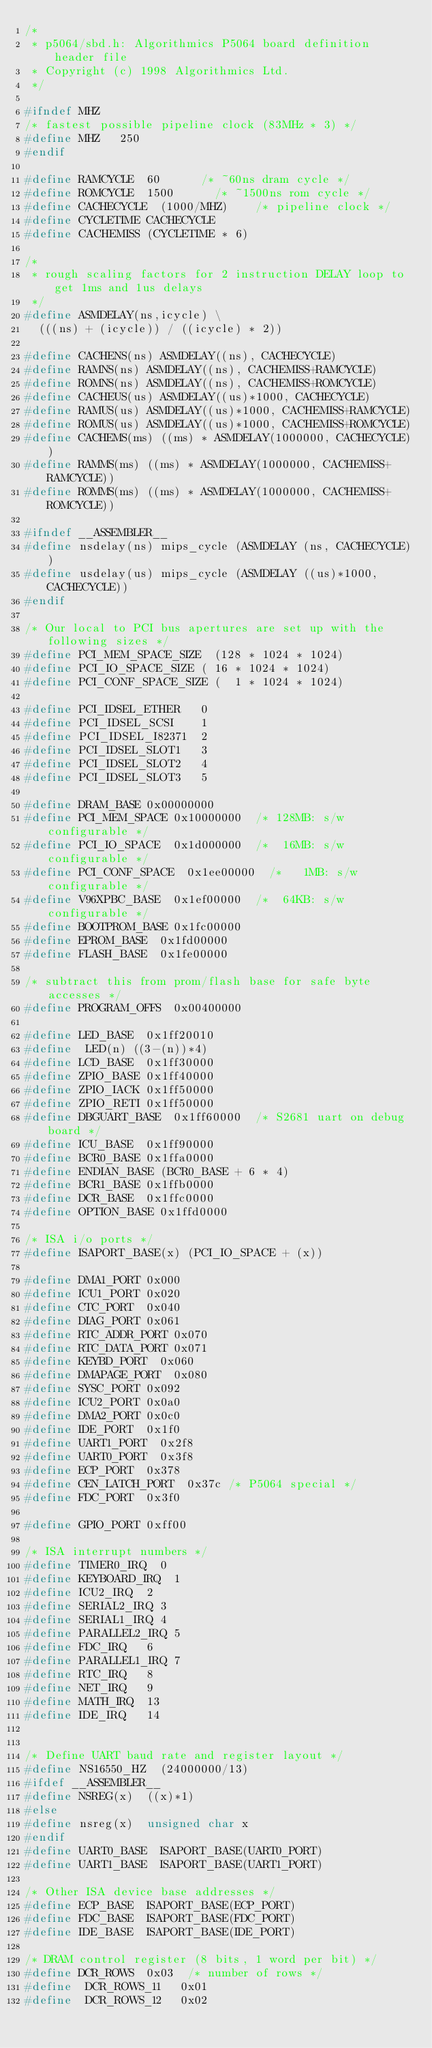<code> <loc_0><loc_0><loc_500><loc_500><_C_>/* 
 * p5064/sbd.h: Algorithmics P5064 board definition header file
 * Copyright (c) 1998 Algorithmics Ltd.
 */

#ifndef MHZ
/* fastest possible pipeline clock (83MHz * 3) */
#define MHZ		250
#endif

#define RAMCYCLE	60			/* ~60ns dram cycle */
#define ROMCYCLE	1500			/* ~1500ns rom cycle */
#define CACHECYCLE	(1000/MHZ) 		/* pipeline clock */
#define CYCLETIME	CACHECYCLE
#define CACHEMISS	(CYCLETIME * 6)

/*
 * rough scaling factors for 2 instruction DELAY loop to get 1ms and 1us delays
 */
#define ASMDELAY(ns,icycle)	\
	(((ns) + (icycle)) / ((icycle) * 2))

#define CACHENS(ns)	ASMDELAY((ns), CACHECYCLE)
#define RAMNS(ns)	ASMDELAY((ns), CACHEMISS+RAMCYCLE)
#define ROMNS(ns)	ASMDELAY((ns), CACHEMISS+ROMCYCLE)
#define CACHEUS(us)	ASMDELAY((us)*1000, CACHECYCLE)
#define RAMUS(us)	ASMDELAY((us)*1000, CACHEMISS+RAMCYCLE)
#define ROMUS(us)	ASMDELAY((us)*1000, CACHEMISS+ROMCYCLE)
#define CACHEMS(ms)	((ms) * ASMDELAY(1000000, CACHECYCLE))
#define RAMMS(ms)	((ms) * ASMDELAY(1000000, CACHEMISS+RAMCYCLE))
#define ROMMS(ms)	((ms) * ASMDELAY(1000000, CACHEMISS+ROMCYCLE))

#ifndef __ASSEMBLER__
#define nsdelay(ns)	mips_cycle (ASMDELAY (ns, CACHECYCLE))
#define usdelay(us)	mips_cycle (ASMDELAY ((us)*1000, CACHECYCLE))
#endif

/* Our local to PCI bus apertures are set up with the following sizes */
#define PCI_MEM_SPACE_SIZE	(128 * 1024 * 1024)
#define PCI_IO_SPACE_SIZE	( 16 * 1024 * 1024)
#define PCI_CONF_SPACE_SIZE	(  1 * 1024 * 1024)

#define PCI_IDSEL_ETHER		0
#define PCI_IDSEL_SCSI		1
#define PCI_IDSEL_I82371	2
#define PCI_IDSEL_SLOT1		3
#define PCI_IDSEL_SLOT2		4
#define PCI_IDSEL_SLOT3		5

#define DRAM_BASE	0x00000000
#define PCI_MEM_SPACE	0x10000000	/* 128MB: s/w configurable */
#define PCI_IO_SPACE	0x1d000000	/*  16MB: s/w configurable */
#define PCI_CONF_SPACE	0x1ee00000	/*   1MB: s/w configurable */
#define V96XPBC_BASE	0x1ef00000	/*  64KB: s/w configurable */
#define BOOTPROM_BASE	0x1fc00000
#define EPROM_BASE	0x1fd00000
#define FLASH_BASE	0x1fe00000

/* subtract this from prom/flash base for safe byte accesses */
#define PROGRAM_OFFS	0x00400000

#define LED_BASE	0x1ff20010
#define  LED(n)	((3-(n))*4)
#define LCD_BASE	0x1ff30000
#define ZPIO_BASE	0x1ff40000
#define ZPIO_IACK	0x1ff50000
#define ZPIO_RETI	0x1ff50000
#define DBGUART_BASE	0x1ff60000	/* S2681 uart on debug board */
#define ICU_BASE	0x1ff90000
#define BCR0_BASE	0x1ffa0000
#define ENDIAN_BASE	(BCR0_BASE + 6 * 4)
#define BCR1_BASE	0x1ffb0000
#define DCR_BASE	0x1ffc0000
#define OPTION_BASE	0x1ffd0000

/* ISA i/o ports */
#define ISAPORT_BASE(x)	(PCI_IO_SPACE + (x))

#define DMA1_PORT	0x000
#define ICU1_PORT	0x020
#define CTC_PORT	0x040
#define DIAG_PORT	0x061
#define RTC_ADDR_PORT	0x070
#define RTC_DATA_PORT	0x071
#define KEYBD_PORT	0x060
#define DMAPAGE_PORT	0x080
#define SYSC_PORT	0x092
#define ICU2_PORT	0x0a0
#define DMA2_PORT	0x0c0
#define IDE_PORT	0x1f0
#define UART1_PORT	0x2f8
#define UART0_PORT	0x3f8
#define ECP_PORT	0x378
#define CEN_LATCH_PORT	0x37c	/* P5064 special */
#define FDC_PORT	0x3f0

#define GPIO_PORT	0xff00

/* ISA interrupt numbers */
#define TIMER0_IRQ	0
#define KEYBOARD_IRQ	1
#define ICU2_IRQ	2
#define SERIAL2_IRQ	3
#define SERIAL1_IRQ	4
#define PARALLEL2_IRQ	5
#define FDC_IRQ		6
#define PARALLEL1_IRQ	7
#define RTC_IRQ		8
#define NET_IRQ		9
#define MATH_IRQ	13
#define IDE_IRQ		14


/* Define UART baud rate and register layout */
#define NS16550_HZ	(24000000/13)
#ifdef __ASSEMBLER__
#define NSREG(x)	((x)*1)
#else
#define nsreg(x)	unsigned char x
#endif
#define UART0_BASE	ISAPORT_BASE(UART0_PORT)
#define UART1_BASE	ISAPORT_BASE(UART1_PORT)

/* Other ISA device base addresses */
#define ECP_BASE	ISAPORT_BASE(ECP_PORT)
#define FDC_BASE	ISAPORT_BASE(FDC_PORT)
#define IDE_BASE	ISAPORT_BASE(IDE_PORT)

/* DRAM control register (8 bits, 1 word per bit) */
#define DCR_ROWS	0x03	/* number of rows */
#define  DCR_ROWS_11	 0x01
#define  DCR_ROWS_12	 0x02</code> 